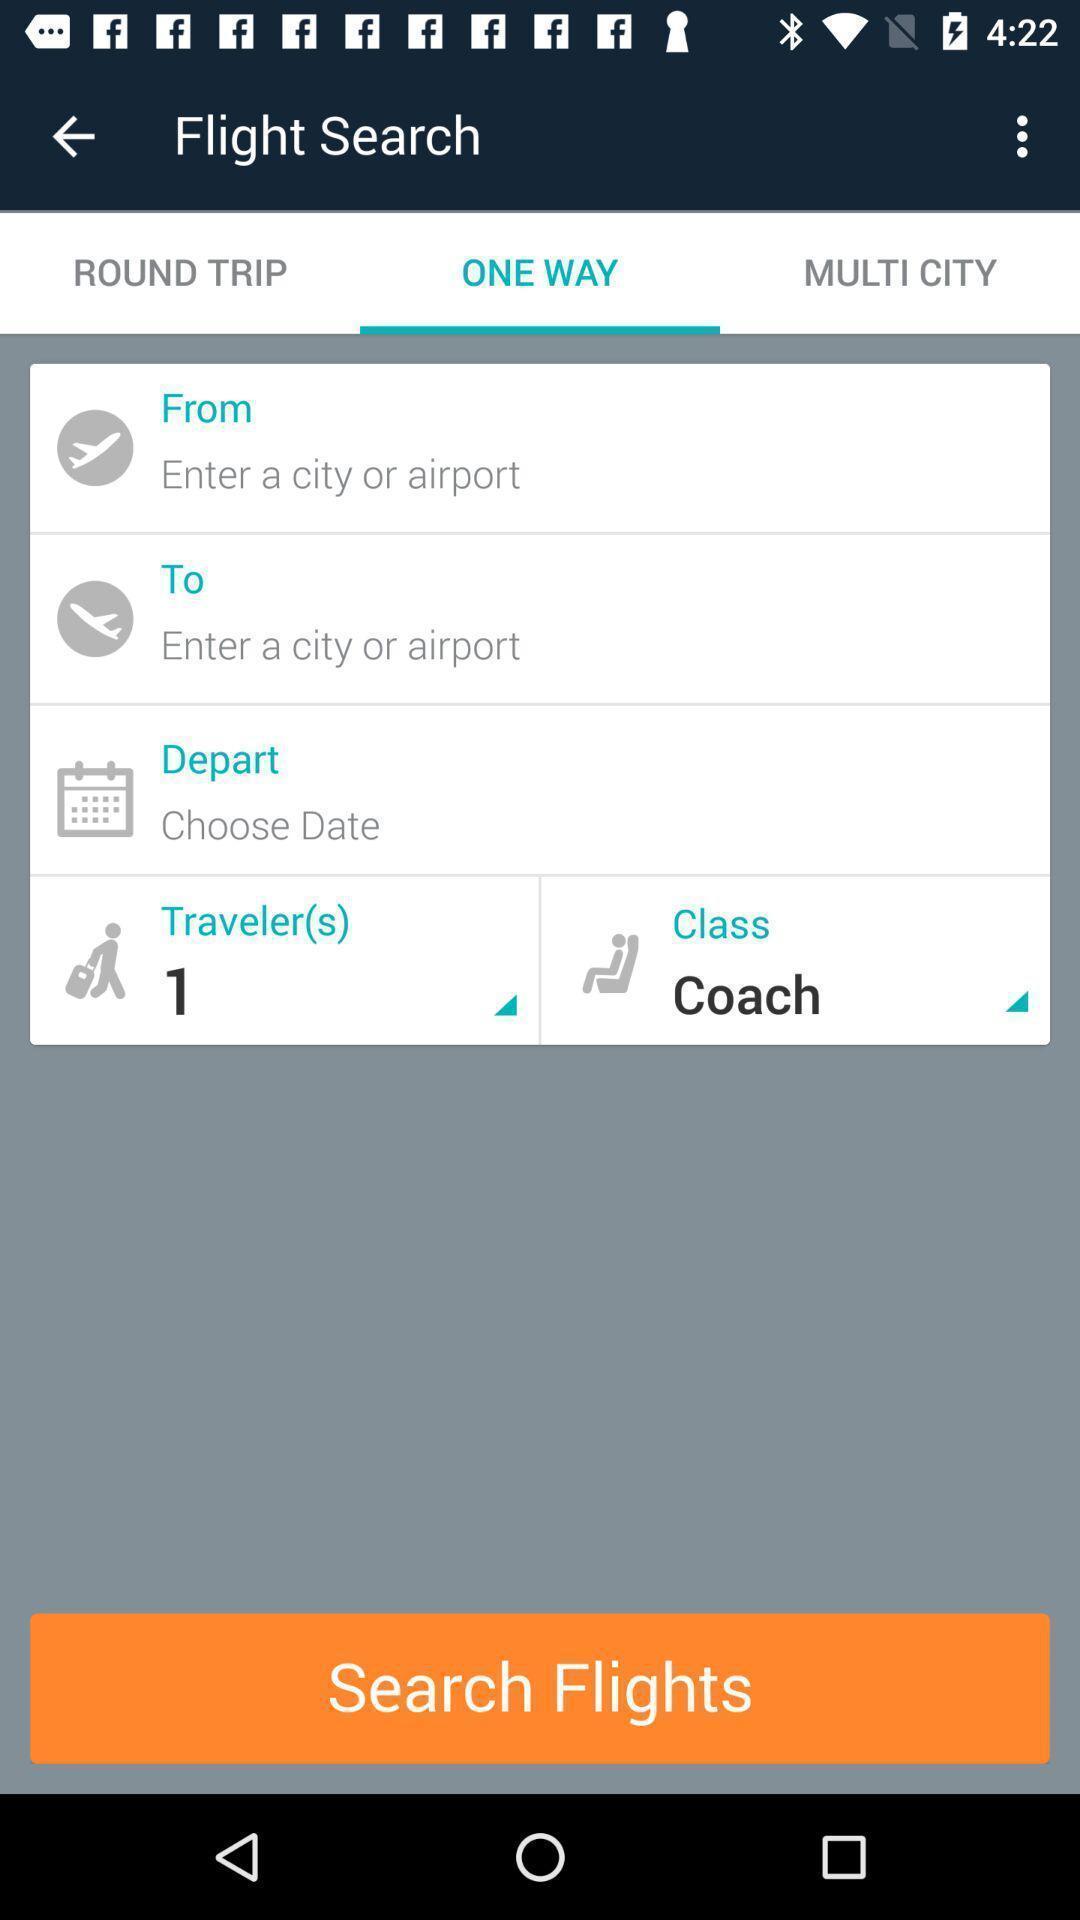Give me a narrative description of this picture. Screen page with different options. 